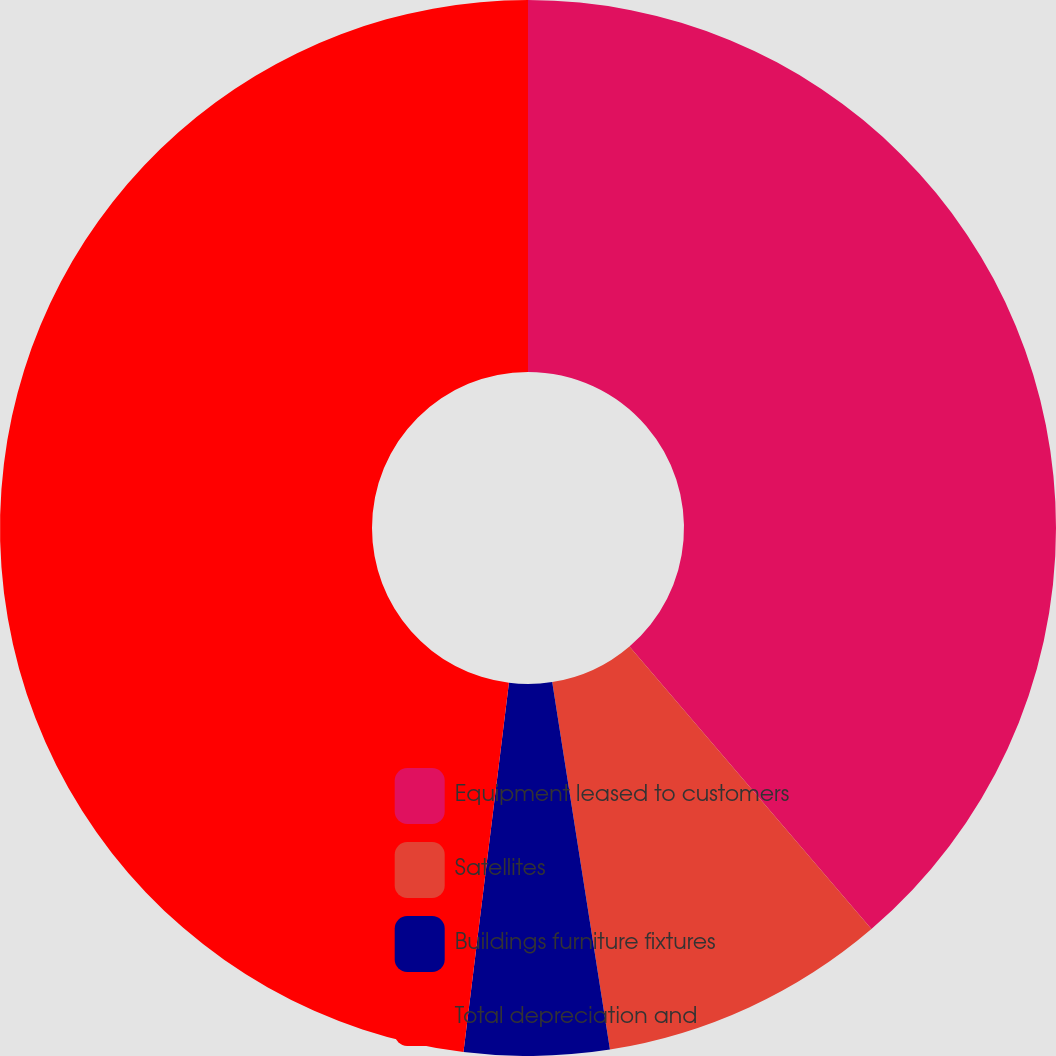<chart> <loc_0><loc_0><loc_500><loc_500><pie_chart><fcel>Equipment leased to customers<fcel>Satellites<fcel>Buildings furniture fixtures<fcel>Total depreciation and<nl><fcel>38.73%<fcel>8.79%<fcel>4.43%<fcel>48.05%<nl></chart> 